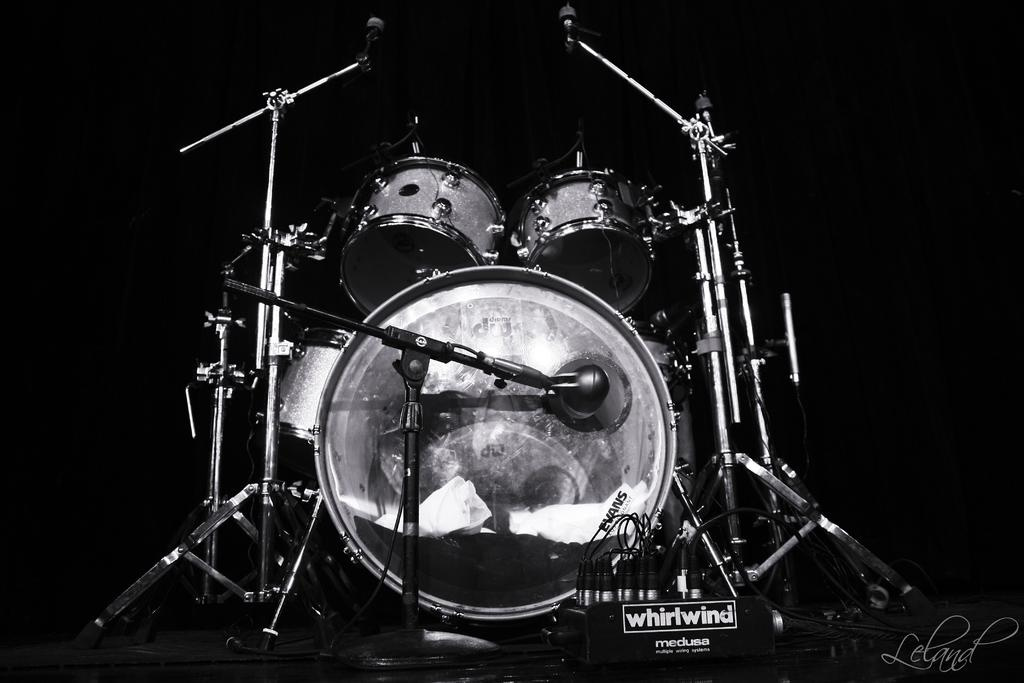What type of equipment is present in the image? There are microphones and drums in the image, along with other musical instruments. What can be inferred about the setting from the background color? The background of the image is black, which could suggest a dark or dimly lit environment. Can you describe the other musical instruments in the image? Unfortunately, the provided facts do not specify the other musical instruments in the image. How many roses are on the floor in the image? There are no roses present in the image. What type of room is depicted in the image? The provided facts do not specify the type of room or setting in the image. 